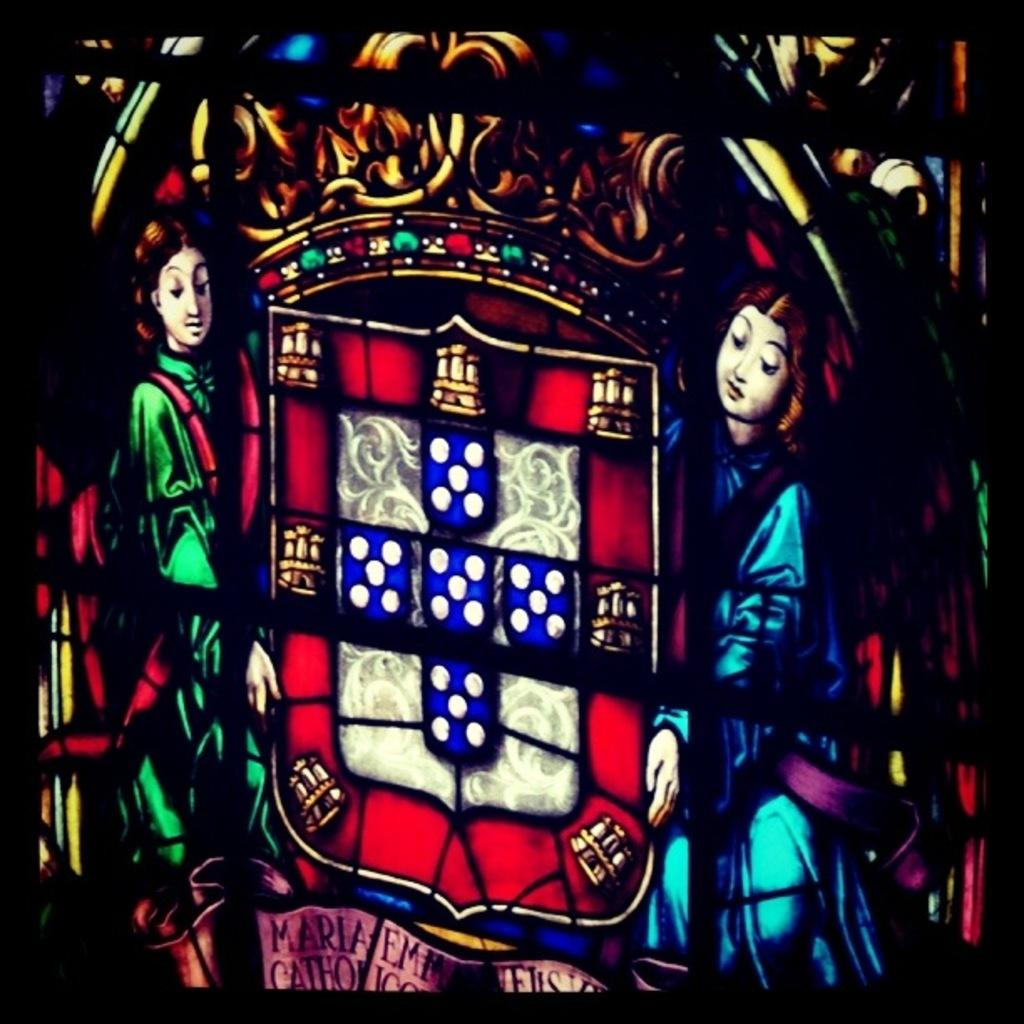What type of image is this? The image appears to be animated. How many persons are in the image? There are two persons in the image, one on the right and one on the left. What are the persons holding in the image? The persons are holding objects. Is there any text present in the image? Yes, there is text at the bottom of the image. What type of food is the person on the right eating in the image? There is no food visible in the image, and the person on the right is not eating anything. Can you see any mint leaves in the image? There are no mint leaves present in the image. 